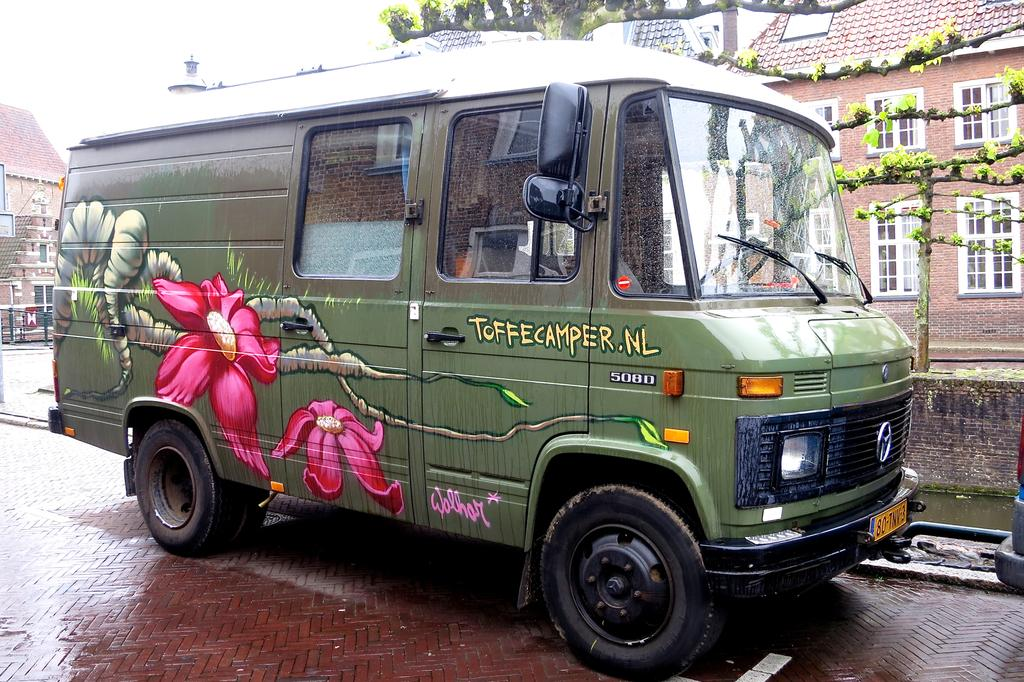<image>
Give a short and clear explanation of the subsequent image. Green and petite truck for ToffeeCamper parked outdoors. 